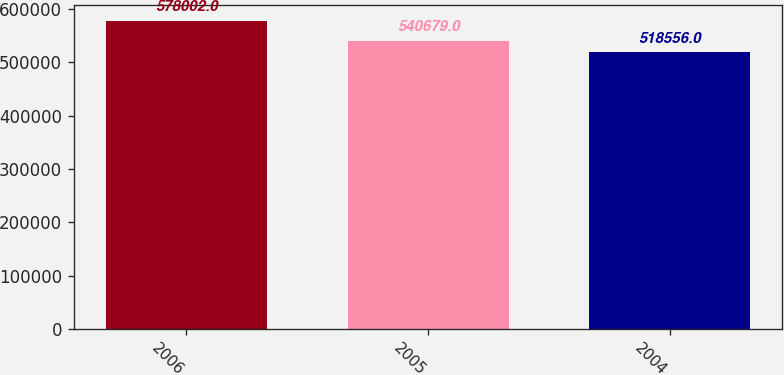<chart> <loc_0><loc_0><loc_500><loc_500><bar_chart><fcel>2006<fcel>2005<fcel>2004<nl><fcel>578002<fcel>540679<fcel>518556<nl></chart> 